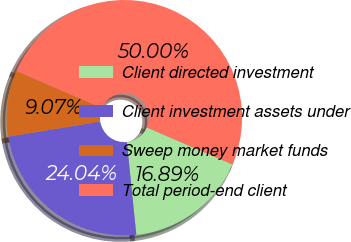Convert chart to OTSL. <chart><loc_0><loc_0><loc_500><loc_500><pie_chart><fcel>Client directed investment<fcel>Client investment assets under<fcel>Sweep money market funds<fcel>Total period-end client<nl><fcel>16.89%<fcel>24.04%<fcel>9.07%<fcel>50.0%<nl></chart> 